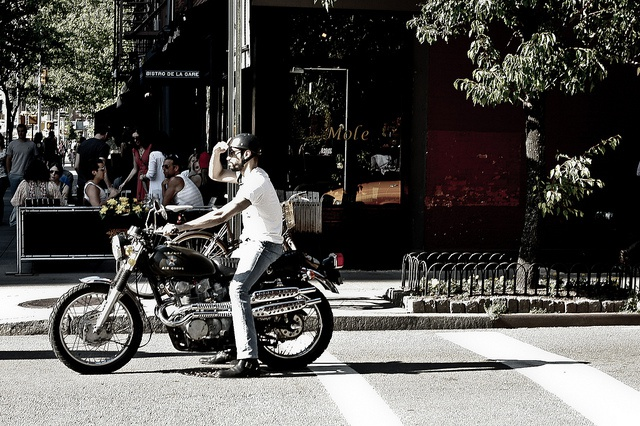Describe the objects in this image and their specific colors. I can see motorcycle in black, gray, lightgray, and darkgray tones, people in black, white, darkgray, and gray tones, people in black, gray, darkgray, and lightgray tones, people in black, gray, and darkgray tones, and people in black, gray, and darkgray tones in this image. 